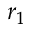Convert formula to latex. <formula><loc_0><loc_0><loc_500><loc_500>r _ { 1 }</formula> 